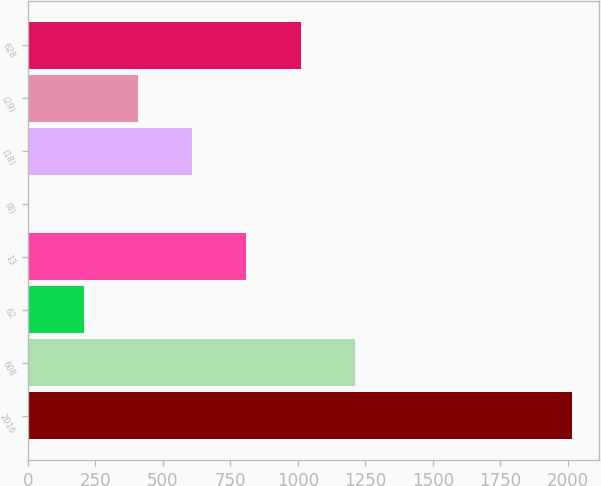<chart> <loc_0><loc_0><loc_500><loc_500><bar_chart><fcel>2016<fcel>608<fcel>62<fcel>13<fcel>(8)<fcel>(18)<fcel>(29)<fcel>628<nl><fcel>2015<fcel>1211.4<fcel>206.9<fcel>809.6<fcel>6<fcel>608.7<fcel>407.8<fcel>1010.5<nl></chart> 